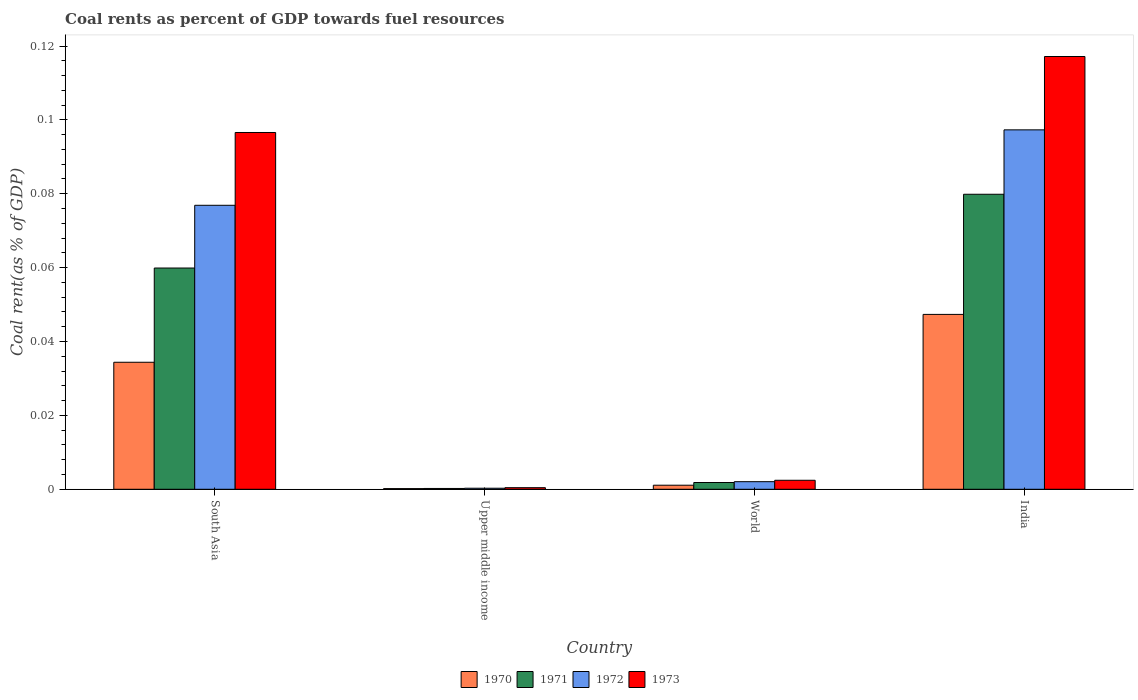How many groups of bars are there?
Keep it short and to the point. 4. Are the number of bars per tick equal to the number of legend labels?
Keep it short and to the point. Yes. Are the number of bars on each tick of the X-axis equal?
Your response must be concise. Yes. How many bars are there on the 1st tick from the right?
Your response must be concise. 4. In how many cases, is the number of bars for a given country not equal to the number of legend labels?
Your answer should be very brief. 0. What is the coal rent in 1972 in World?
Provide a succinct answer. 0. Across all countries, what is the maximum coal rent in 1970?
Make the answer very short. 0.05. Across all countries, what is the minimum coal rent in 1972?
Ensure brevity in your answer.  0. In which country was the coal rent in 1972 minimum?
Your answer should be very brief. Upper middle income. What is the total coal rent in 1973 in the graph?
Ensure brevity in your answer.  0.22. What is the difference between the coal rent in 1970 in India and that in Upper middle income?
Your answer should be compact. 0.05. What is the difference between the coal rent in 1972 in World and the coal rent in 1971 in Upper middle income?
Offer a terse response. 0. What is the average coal rent in 1970 per country?
Your answer should be compact. 0.02. What is the difference between the coal rent of/in 1971 and coal rent of/in 1972 in South Asia?
Your answer should be compact. -0.02. In how many countries, is the coal rent in 1971 greater than 0.10400000000000001 %?
Ensure brevity in your answer.  0. What is the ratio of the coal rent in 1973 in South Asia to that in Upper middle income?
Ensure brevity in your answer.  224.18. What is the difference between the highest and the second highest coal rent in 1972?
Offer a very short reply. 0.1. What is the difference between the highest and the lowest coal rent in 1970?
Give a very brief answer. 0.05. Is the sum of the coal rent in 1971 in India and South Asia greater than the maximum coal rent in 1972 across all countries?
Ensure brevity in your answer.  Yes. Is it the case that in every country, the sum of the coal rent in 1972 and coal rent in 1973 is greater than the sum of coal rent in 1970 and coal rent in 1971?
Provide a short and direct response. No. What does the 2nd bar from the right in South Asia represents?
Ensure brevity in your answer.  1972. Is it the case that in every country, the sum of the coal rent in 1971 and coal rent in 1973 is greater than the coal rent in 1970?
Ensure brevity in your answer.  Yes. How many bars are there?
Provide a succinct answer. 16. Are all the bars in the graph horizontal?
Make the answer very short. No. How many countries are there in the graph?
Your answer should be compact. 4. What is the difference between two consecutive major ticks on the Y-axis?
Ensure brevity in your answer.  0.02. Are the values on the major ticks of Y-axis written in scientific E-notation?
Your answer should be very brief. No. Does the graph contain any zero values?
Your response must be concise. No. How many legend labels are there?
Provide a succinct answer. 4. What is the title of the graph?
Provide a succinct answer. Coal rents as percent of GDP towards fuel resources. Does "1969" appear as one of the legend labels in the graph?
Give a very brief answer. No. What is the label or title of the Y-axis?
Offer a terse response. Coal rent(as % of GDP). What is the Coal rent(as % of GDP) in 1970 in South Asia?
Your answer should be compact. 0.03. What is the Coal rent(as % of GDP) of 1971 in South Asia?
Ensure brevity in your answer.  0.06. What is the Coal rent(as % of GDP) in 1972 in South Asia?
Keep it short and to the point. 0.08. What is the Coal rent(as % of GDP) of 1973 in South Asia?
Offer a terse response. 0.1. What is the Coal rent(as % of GDP) of 1970 in Upper middle income?
Your answer should be very brief. 0. What is the Coal rent(as % of GDP) in 1971 in Upper middle income?
Offer a very short reply. 0. What is the Coal rent(as % of GDP) in 1972 in Upper middle income?
Your response must be concise. 0. What is the Coal rent(as % of GDP) of 1973 in Upper middle income?
Provide a short and direct response. 0. What is the Coal rent(as % of GDP) in 1970 in World?
Provide a succinct answer. 0. What is the Coal rent(as % of GDP) of 1971 in World?
Make the answer very short. 0. What is the Coal rent(as % of GDP) of 1972 in World?
Offer a very short reply. 0. What is the Coal rent(as % of GDP) in 1973 in World?
Make the answer very short. 0. What is the Coal rent(as % of GDP) of 1970 in India?
Offer a terse response. 0.05. What is the Coal rent(as % of GDP) in 1971 in India?
Make the answer very short. 0.08. What is the Coal rent(as % of GDP) in 1972 in India?
Your response must be concise. 0.1. What is the Coal rent(as % of GDP) of 1973 in India?
Your answer should be very brief. 0.12. Across all countries, what is the maximum Coal rent(as % of GDP) of 1970?
Your response must be concise. 0.05. Across all countries, what is the maximum Coal rent(as % of GDP) of 1971?
Provide a succinct answer. 0.08. Across all countries, what is the maximum Coal rent(as % of GDP) of 1972?
Your answer should be very brief. 0.1. Across all countries, what is the maximum Coal rent(as % of GDP) of 1973?
Make the answer very short. 0.12. Across all countries, what is the minimum Coal rent(as % of GDP) of 1970?
Your response must be concise. 0. Across all countries, what is the minimum Coal rent(as % of GDP) of 1971?
Give a very brief answer. 0. Across all countries, what is the minimum Coal rent(as % of GDP) in 1972?
Provide a short and direct response. 0. Across all countries, what is the minimum Coal rent(as % of GDP) of 1973?
Provide a short and direct response. 0. What is the total Coal rent(as % of GDP) in 1970 in the graph?
Offer a terse response. 0.08. What is the total Coal rent(as % of GDP) in 1971 in the graph?
Provide a short and direct response. 0.14. What is the total Coal rent(as % of GDP) of 1972 in the graph?
Give a very brief answer. 0.18. What is the total Coal rent(as % of GDP) in 1973 in the graph?
Make the answer very short. 0.22. What is the difference between the Coal rent(as % of GDP) of 1970 in South Asia and that in Upper middle income?
Ensure brevity in your answer.  0.03. What is the difference between the Coal rent(as % of GDP) in 1971 in South Asia and that in Upper middle income?
Make the answer very short. 0.06. What is the difference between the Coal rent(as % of GDP) in 1972 in South Asia and that in Upper middle income?
Offer a terse response. 0.08. What is the difference between the Coal rent(as % of GDP) in 1973 in South Asia and that in Upper middle income?
Provide a short and direct response. 0.1. What is the difference between the Coal rent(as % of GDP) of 1970 in South Asia and that in World?
Make the answer very short. 0.03. What is the difference between the Coal rent(as % of GDP) of 1971 in South Asia and that in World?
Make the answer very short. 0.06. What is the difference between the Coal rent(as % of GDP) in 1972 in South Asia and that in World?
Your answer should be compact. 0.07. What is the difference between the Coal rent(as % of GDP) in 1973 in South Asia and that in World?
Make the answer very short. 0.09. What is the difference between the Coal rent(as % of GDP) of 1970 in South Asia and that in India?
Make the answer very short. -0.01. What is the difference between the Coal rent(as % of GDP) in 1971 in South Asia and that in India?
Your answer should be compact. -0.02. What is the difference between the Coal rent(as % of GDP) in 1972 in South Asia and that in India?
Provide a succinct answer. -0.02. What is the difference between the Coal rent(as % of GDP) of 1973 in South Asia and that in India?
Ensure brevity in your answer.  -0.02. What is the difference between the Coal rent(as % of GDP) in 1970 in Upper middle income and that in World?
Give a very brief answer. -0. What is the difference between the Coal rent(as % of GDP) of 1971 in Upper middle income and that in World?
Provide a short and direct response. -0. What is the difference between the Coal rent(as % of GDP) in 1972 in Upper middle income and that in World?
Provide a succinct answer. -0. What is the difference between the Coal rent(as % of GDP) of 1973 in Upper middle income and that in World?
Ensure brevity in your answer.  -0. What is the difference between the Coal rent(as % of GDP) in 1970 in Upper middle income and that in India?
Provide a short and direct response. -0.05. What is the difference between the Coal rent(as % of GDP) in 1971 in Upper middle income and that in India?
Your answer should be compact. -0.08. What is the difference between the Coal rent(as % of GDP) in 1972 in Upper middle income and that in India?
Give a very brief answer. -0.1. What is the difference between the Coal rent(as % of GDP) in 1973 in Upper middle income and that in India?
Make the answer very short. -0.12. What is the difference between the Coal rent(as % of GDP) of 1970 in World and that in India?
Keep it short and to the point. -0.05. What is the difference between the Coal rent(as % of GDP) in 1971 in World and that in India?
Provide a succinct answer. -0.08. What is the difference between the Coal rent(as % of GDP) in 1972 in World and that in India?
Make the answer very short. -0.1. What is the difference between the Coal rent(as % of GDP) in 1973 in World and that in India?
Provide a short and direct response. -0.11. What is the difference between the Coal rent(as % of GDP) of 1970 in South Asia and the Coal rent(as % of GDP) of 1971 in Upper middle income?
Provide a short and direct response. 0.03. What is the difference between the Coal rent(as % of GDP) in 1970 in South Asia and the Coal rent(as % of GDP) in 1972 in Upper middle income?
Offer a very short reply. 0.03. What is the difference between the Coal rent(as % of GDP) in 1970 in South Asia and the Coal rent(as % of GDP) in 1973 in Upper middle income?
Your answer should be very brief. 0.03. What is the difference between the Coal rent(as % of GDP) in 1971 in South Asia and the Coal rent(as % of GDP) in 1972 in Upper middle income?
Offer a very short reply. 0.06. What is the difference between the Coal rent(as % of GDP) of 1971 in South Asia and the Coal rent(as % of GDP) of 1973 in Upper middle income?
Ensure brevity in your answer.  0.06. What is the difference between the Coal rent(as % of GDP) of 1972 in South Asia and the Coal rent(as % of GDP) of 1973 in Upper middle income?
Your answer should be very brief. 0.08. What is the difference between the Coal rent(as % of GDP) in 1970 in South Asia and the Coal rent(as % of GDP) in 1971 in World?
Keep it short and to the point. 0.03. What is the difference between the Coal rent(as % of GDP) in 1970 in South Asia and the Coal rent(as % of GDP) in 1972 in World?
Ensure brevity in your answer.  0.03. What is the difference between the Coal rent(as % of GDP) in 1970 in South Asia and the Coal rent(as % of GDP) in 1973 in World?
Ensure brevity in your answer.  0.03. What is the difference between the Coal rent(as % of GDP) of 1971 in South Asia and the Coal rent(as % of GDP) of 1972 in World?
Provide a short and direct response. 0.06. What is the difference between the Coal rent(as % of GDP) of 1971 in South Asia and the Coal rent(as % of GDP) of 1973 in World?
Offer a terse response. 0.06. What is the difference between the Coal rent(as % of GDP) in 1972 in South Asia and the Coal rent(as % of GDP) in 1973 in World?
Make the answer very short. 0.07. What is the difference between the Coal rent(as % of GDP) in 1970 in South Asia and the Coal rent(as % of GDP) in 1971 in India?
Ensure brevity in your answer.  -0.05. What is the difference between the Coal rent(as % of GDP) of 1970 in South Asia and the Coal rent(as % of GDP) of 1972 in India?
Your answer should be very brief. -0.06. What is the difference between the Coal rent(as % of GDP) of 1970 in South Asia and the Coal rent(as % of GDP) of 1973 in India?
Ensure brevity in your answer.  -0.08. What is the difference between the Coal rent(as % of GDP) of 1971 in South Asia and the Coal rent(as % of GDP) of 1972 in India?
Give a very brief answer. -0.04. What is the difference between the Coal rent(as % of GDP) in 1971 in South Asia and the Coal rent(as % of GDP) in 1973 in India?
Provide a short and direct response. -0.06. What is the difference between the Coal rent(as % of GDP) of 1972 in South Asia and the Coal rent(as % of GDP) of 1973 in India?
Keep it short and to the point. -0.04. What is the difference between the Coal rent(as % of GDP) in 1970 in Upper middle income and the Coal rent(as % of GDP) in 1971 in World?
Your answer should be compact. -0. What is the difference between the Coal rent(as % of GDP) in 1970 in Upper middle income and the Coal rent(as % of GDP) in 1972 in World?
Ensure brevity in your answer.  -0. What is the difference between the Coal rent(as % of GDP) in 1970 in Upper middle income and the Coal rent(as % of GDP) in 1973 in World?
Give a very brief answer. -0. What is the difference between the Coal rent(as % of GDP) of 1971 in Upper middle income and the Coal rent(as % of GDP) of 1972 in World?
Offer a very short reply. -0. What is the difference between the Coal rent(as % of GDP) of 1971 in Upper middle income and the Coal rent(as % of GDP) of 1973 in World?
Provide a short and direct response. -0. What is the difference between the Coal rent(as % of GDP) of 1972 in Upper middle income and the Coal rent(as % of GDP) of 1973 in World?
Provide a short and direct response. -0. What is the difference between the Coal rent(as % of GDP) in 1970 in Upper middle income and the Coal rent(as % of GDP) in 1971 in India?
Keep it short and to the point. -0.08. What is the difference between the Coal rent(as % of GDP) of 1970 in Upper middle income and the Coal rent(as % of GDP) of 1972 in India?
Your response must be concise. -0.1. What is the difference between the Coal rent(as % of GDP) of 1970 in Upper middle income and the Coal rent(as % of GDP) of 1973 in India?
Your answer should be compact. -0.12. What is the difference between the Coal rent(as % of GDP) in 1971 in Upper middle income and the Coal rent(as % of GDP) in 1972 in India?
Your answer should be compact. -0.1. What is the difference between the Coal rent(as % of GDP) of 1971 in Upper middle income and the Coal rent(as % of GDP) of 1973 in India?
Offer a very short reply. -0.12. What is the difference between the Coal rent(as % of GDP) of 1972 in Upper middle income and the Coal rent(as % of GDP) of 1973 in India?
Your response must be concise. -0.12. What is the difference between the Coal rent(as % of GDP) in 1970 in World and the Coal rent(as % of GDP) in 1971 in India?
Ensure brevity in your answer.  -0.08. What is the difference between the Coal rent(as % of GDP) of 1970 in World and the Coal rent(as % of GDP) of 1972 in India?
Ensure brevity in your answer.  -0.1. What is the difference between the Coal rent(as % of GDP) of 1970 in World and the Coal rent(as % of GDP) of 1973 in India?
Your response must be concise. -0.12. What is the difference between the Coal rent(as % of GDP) in 1971 in World and the Coal rent(as % of GDP) in 1972 in India?
Give a very brief answer. -0.1. What is the difference between the Coal rent(as % of GDP) of 1971 in World and the Coal rent(as % of GDP) of 1973 in India?
Your response must be concise. -0.12. What is the difference between the Coal rent(as % of GDP) of 1972 in World and the Coal rent(as % of GDP) of 1973 in India?
Provide a short and direct response. -0.12. What is the average Coal rent(as % of GDP) in 1970 per country?
Ensure brevity in your answer.  0.02. What is the average Coal rent(as % of GDP) of 1971 per country?
Provide a short and direct response. 0.04. What is the average Coal rent(as % of GDP) of 1972 per country?
Offer a very short reply. 0.04. What is the average Coal rent(as % of GDP) of 1973 per country?
Your answer should be very brief. 0.05. What is the difference between the Coal rent(as % of GDP) in 1970 and Coal rent(as % of GDP) in 1971 in South Asia?
Offer a very short reply. -0.03. What is the difference between the Coal rent(as % of GDP) of 1970 and Coal rent(as % of GDP) of 1972 in South Asia?
Your response must be concise. -0.04. What is the difference between the Coal rent(as % of GDP) in 1970 and Coal rent(as % of GDP) in 1973 in South Asia?
Your response must be concise. -0.06. What is the difference between the Coal rent(as % of GDP) of 1971 and Coal rent(as % of GDP) of 1972 in South Asia?
Keep it short and to the point. -0.02. What is the difference between the Coal rent(as % of GDP) of 1971 and Coal rent(as % of GDP) of 1973 in South Asia?
Offer a terse response. -0.04. What is the difference between the Coal rent(as % of GDP) in 1972 and Coal rent(as % of GDP) in 1973 in South Asia?
Give a very brief answer. -0.02. What is the difference between the Coal rent(as % of GDP) in 1970 and Coal rent(as % of GDP) in 1971 in Upper middle income?
Make the answer very short. -0. What is the difference between the Coal rent(as % of GDP) in 1970 and Coal rent(as % of GDP) in 1972 in Upper middle income?
Keep it short and to the point. -0. What is the difference between the Coal rent(as % of GDP) of 1970 and Coal rent(as % of GDP) of 1973 in Upper middle income?
Provide a short and direct response. -0. What is the difference between the Coal rent(as % of GDP) of 1971 and Coal rent(as % of GDP) of 1972 in Upper middle income?
Offer a very short reply. -0. What is the difference between the Coal rent(as % of GDP) of 1971 and Coal rent(as % of GDP) of 1973 in Upper middle income?
Your answer should be very brief. -0. What is the difference between the Coal rent(as % of GDP) of 1972 and Coal rent(as % of GDP) of 1973 in Upper middle income?
Ensure brevity in your answer.  -0. What is the difference between the Coal rent(as % of GDP) of 1970 and Coal rent(as % of GDP) of 1971 in World?
Provide a succinct answer. -0. What is the difference between the Coal rent(as % of GDP) in 1970 and Coal rent(as % of GDP) in 1972 in World?
Keep it short and to the point. -0. What is the difference between the Coal rent(as % of GDP) of 1970 and Coal rent(as % of GDP) of 1973 in World?
Keep it short and to the point. -0. What is the difference between the Coal rent(as % of GDP) in 1971 and Coal rent(as % of GDP) in 1972 in World?
Your response must be concise. -0. What is the difference between the Coal rent(as % of GDP) of 1971 and Coal rent(as % of GDP) of 1973 in World?
Your answer should be compact. -0. What is the difference between the Coal rent(as % of GDP) in 1972 and Coal rent(as % of GDP) in 1973 in World?
Keep it short and to the point. -0. What is the difference between the Coal rent(as % of GDP) of 1970 and Coal rent(as % of GDP) of 1971 in India?
Your answer should be compact. -0.03. What is the difference between the Coal rent(as % of GDP) in 1970 and Coal rent(as % of GDP) in 1973 in India?
Your response must be concise. -0.07. What is the difference between the Coal rent(as % of GDP) of 1971 and Coal rent(as % of GDP) of 1972 in India?
Provide a succinct answer. -0.02. What is the difference between the Coal rent(as % of GDP) of 1971 and Coal rent(as % of GDP) of 1973 in India?
Your answer should be compact. -0.04. What is the difference between the Coal rent(as % of GDP) of 1972 and Coal rent(as % of GDP) of 1973 in India?
Your answer should be compact. -0.02. What is the ratio of the Coal rent(as % of GDP) of 1970 in South Asia to that in Upper middle income?
Keep it short and to the point. 187.05. What is the ratio of the Coal rent(as % of GDP) of 1971 in South Asia to that in Upper middle income?
Your answer should be very brief. 273.74. What is the ratio of the Coal rent(as % of GDP) in 1972 in South Asia to that in Upper middle income?
Provide a succinct answer. 270.32. What is the ratio of the Coal rent(as % of GDP) in 1973 in South Asia to that in Upper middle income?
Keep it short and to the point. 224.18. What is the ratio of the Coal rent(as % of GDP) in 1970 in South Asia to that in World?
Your answer should be very brief. 31.24. What is the ratio of the Coal rent(as % of GDP) in 1971 in South Asia to that in World?
Provide a succinct answer. 32.69. What is the ratio of the Coal rent(as % of GDP) of 1972 in South Asia to that in World?
Your answer should be very brief. 37.41. What is the ratio of the Coal rent(as % of GDP) of 1973 in South Asia to that in World?
Your response must be concise. 39.65. What is the ratio of the Coal rent(as % of GDP) of 1970 in South Asia to that in India?
Offer a terse response. 0.73. What is the ratio of the Coal rent(as % of GDP) in 1971 in South Asia to that in India?
Make the answer very short. 0.75. What is the ratio of the Coal rent(as % of GDP) of 1972 in South Asia to that in India?
Provide a succinct answer. 0.79. What is the ratio of the Coal rent(as % of GDP) of 1973 in South Asia to that in India?
Offer a very short reply. 0.82. What is the ratio of the Coal rent(as % of GDP) of 1970 in Upper middle income to that in World?
Offer a terse response. 0.17. What is the ratio of the Coal rent(as % of GDP) of 1971 in Upper middle income to that in World?
Make the answer very short. 0.12. What is the ratio of the Coal rent(as % of GDP) in 1972 in Upper middle income to that in World?
Your response must be concise. 0.14. What is the ratio of the Coal rent(as % of GDP) in 1973 in Upper middle income to that in World?
Your answer should be very brief. 0.18. What is the ratio of the Coal rent(as % of GDP) of 1970 in Upper middle income to that in India?
Provide a succinct answer. 0. What is the ratio of the Coal rent(as % of GDP) in 1971 in Upper middle income to that in India?
Offer a terse response. 0. What is the ratio of the Coal rent(as % of GDP) of 1972 in Upper middle income to that in India?
Your answer should be very brief. 0. What is the ratio of the Coal rent(as % of GDP) in 1973 in Upper middle income to that in India?
Keep it short and to the point. 0. What is the ratio of the Coal rent(as % of GDP) in 1970 in World to that in India?
Provide a short and direct response. 0.02. What is the ratio of the Coal rent(as % of GDP) of 1971 in World to that in India?
Your answer should be very brief. 0.02. What is the ratio of the Coal rent(as % of GDP) in 1972 in World to that in India?
Keep it short and to the point. 0.02. What is the ratio of the Coal rent(as % of GDP) of 1973 in World to that in India?
Provide a succinct answer. 0.02. What is the difference between the highest and the second highest Coal rent(as % of GDP) of 1970?
Ensure brevity in your answer.  0.01. What is the difference between the highest and the second highest Coal rent(as % of GDP) in 1971?
Provide a succinct answer. 0.02. What is the difference between the highest and the second highest Coal rent(as % of GDP) of 1972?
Your response must be concise. 0.02. What is the difference between the highest and the second highest Coal rent(as % of GDP) in 1973?
Offer a terse response. 0.02. What is the difference between the highest and the lowest Coal rent(as % of GDP) in 1970?
Ensure brevity in your answer.  0.05. What is the difference between the highest and the lowest Coal rent(as % of GDP) in 1971?
Make the answer very short. 0.08. What is the difference between the highest and the lowest Coal rent(as % of GDP) in 1972?
Give a very brief answer. 0.1. What is the difference between the highest and the lowest Coal rent(as % of GDP) of 1973?
Your answer should be very brief. 0.12. 